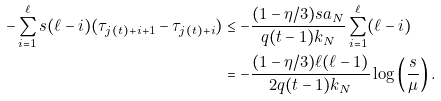<formula> <loc_0><loc_0><loc_500><loc_500>- \sum _ { i = 1 } ^ { \ell } s ( \ell - i ) ( \tau _ { j ( t ) + i + 1 } - \tau _ { j ( t ) + i } ) & \leq - \frac { ( 1 - \eta / 3 ) s a _ { N } } { q ( t - 1 ) k _ { N } } \sum _ { i = 1 } ^ { \ell } ( \ell - i ) \\ & = - \frac { ( 1 - \eta / 3 ) \ell ( \ell - 1 ) } { 2 q ( t - 1 ) k _ { N } } \log \left ( \frac { s } { \mu } \right ) .</formula> 